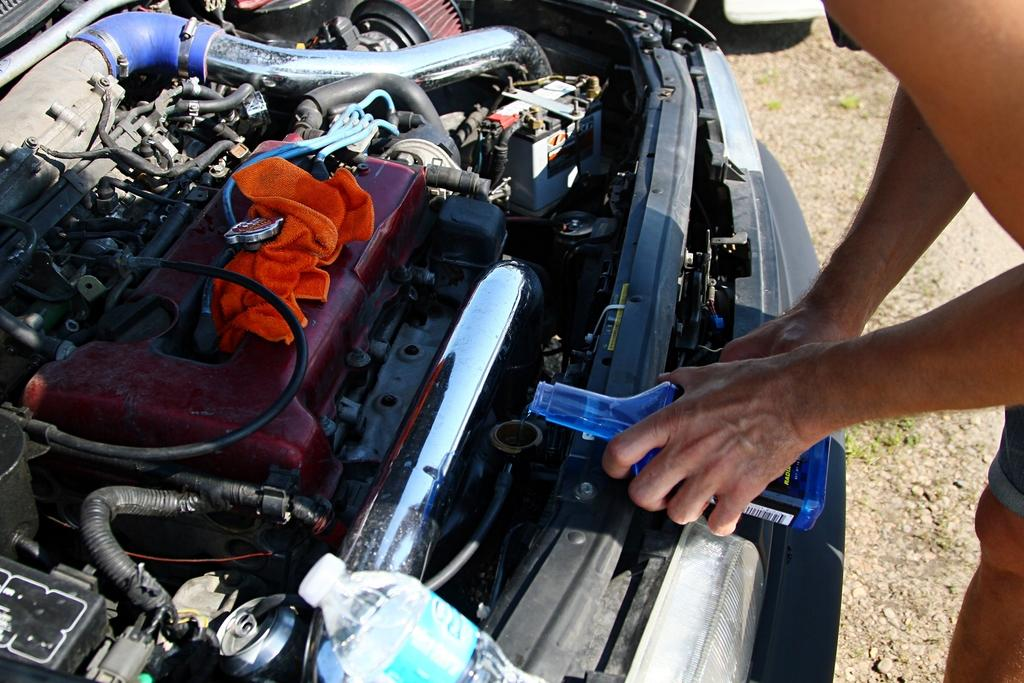Who or what is present in the image? There is a person in the image. What is the person holding in their hand? The person is holding a bottle in their hand. What can be seen in the background of the image? There is an engine visible in the image. Can you identify the type of bottle the person is holding? Yes, there is a water bottle in the image. What type of natural environment is visible in the image? There is grass visible in the image. How many balls are being juggled by the person in the image? There are no balls present in the image; the person is holding a bottle. 